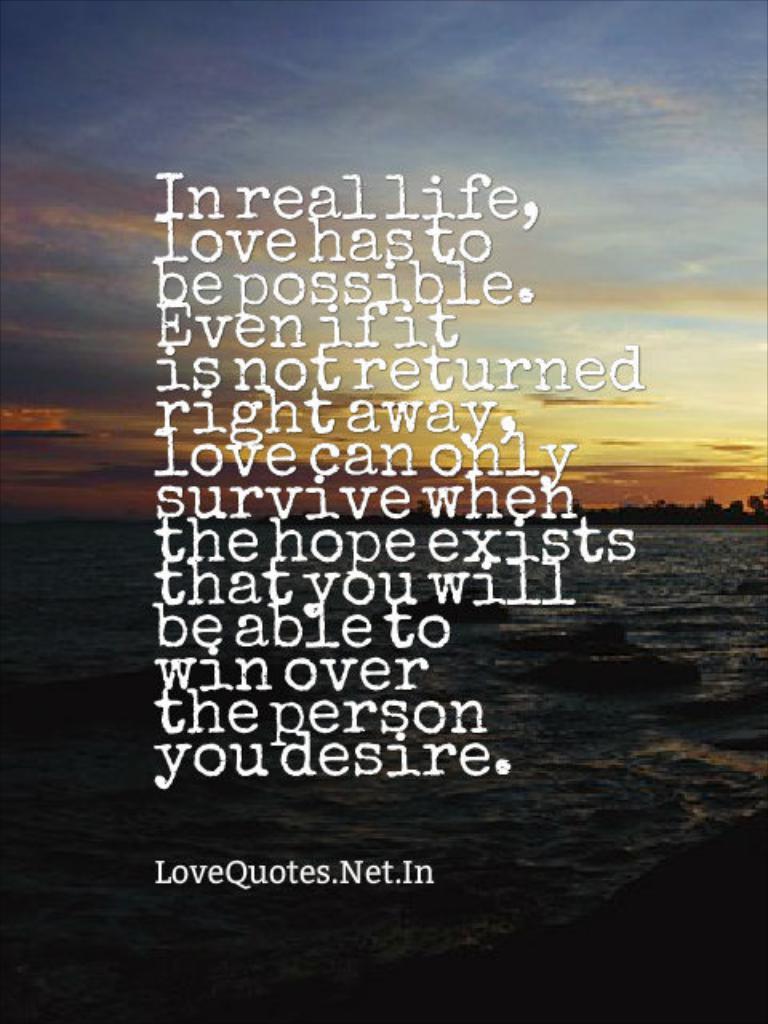Where is this quote from?
Your answer should be very brief. Lovequotes.net.in. What does the quote say?
Provide a succinct answer. In real life, love gas to be possible. 